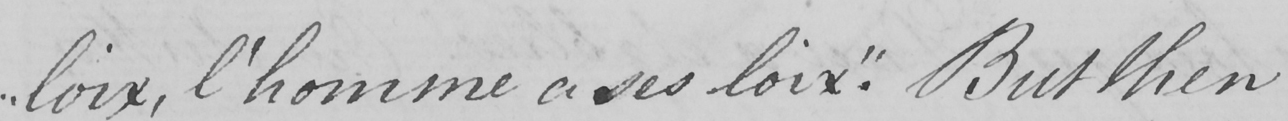Transcribe the text shown in this historical manuscript line. " loix , l ' homme a ses loix . "  But then 